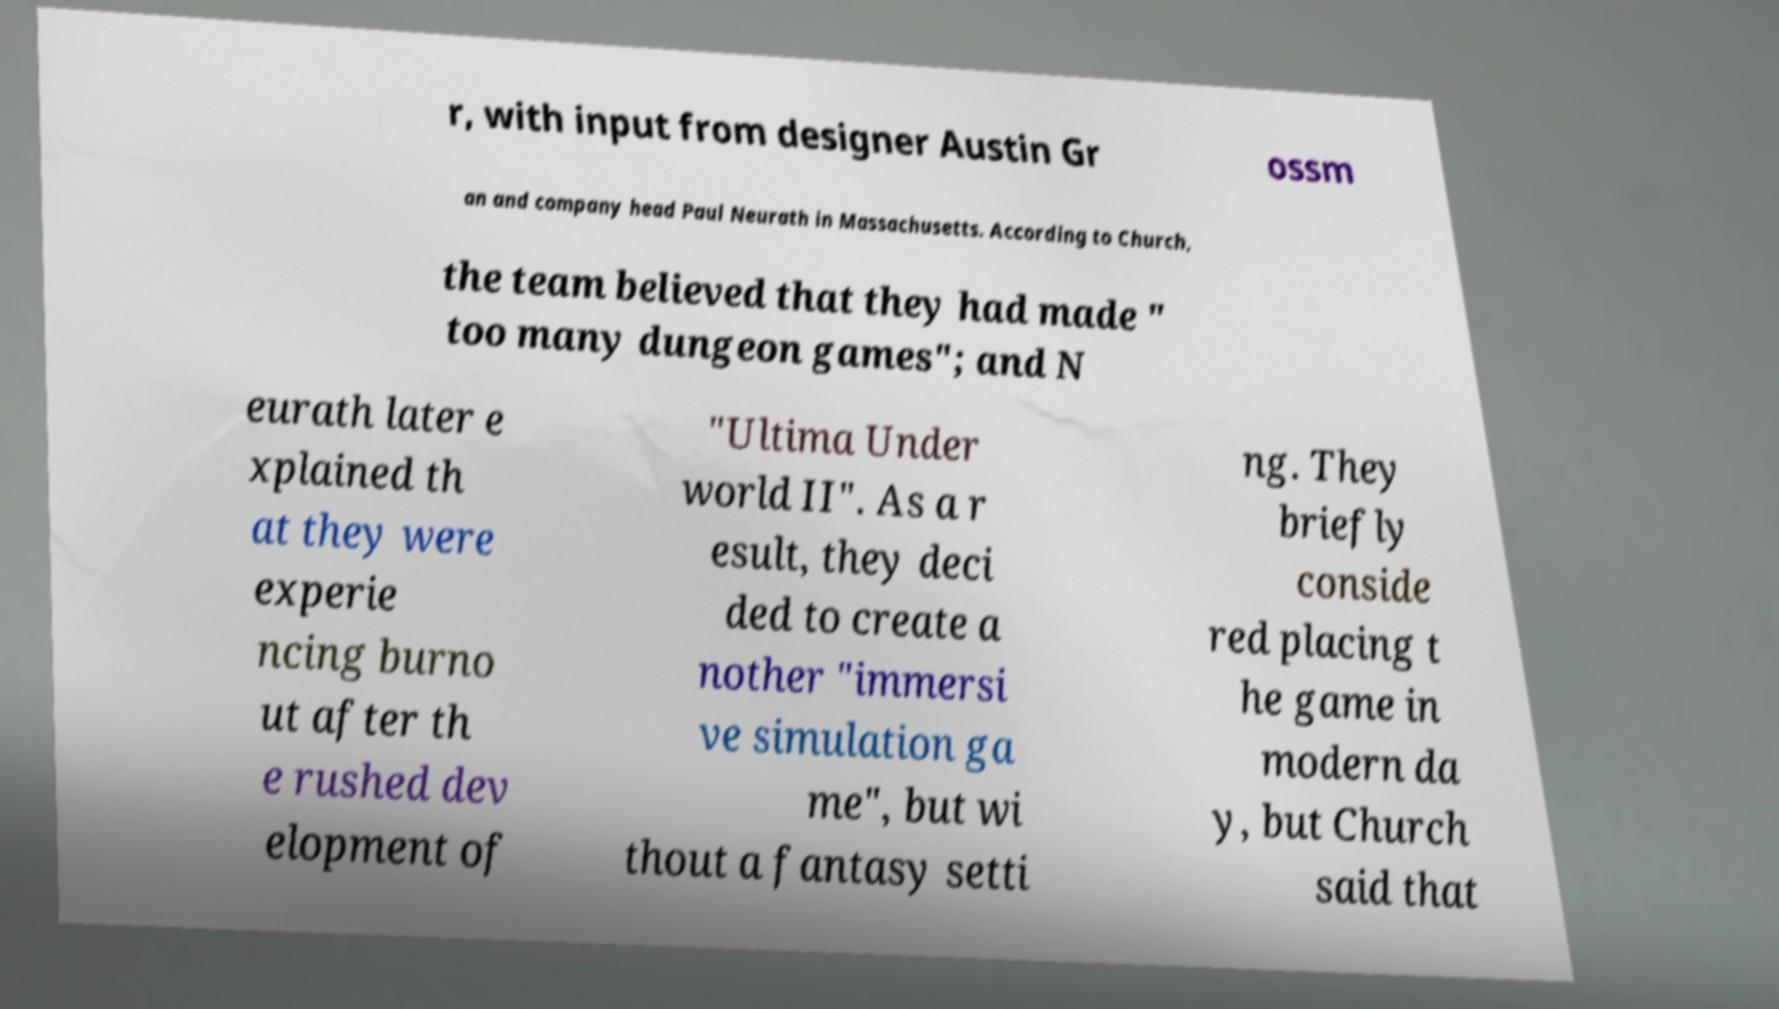I need the written content from this picture converted into text. Can you do that? r, with input from designer Austin Gr ossm an and company head Paul Neurath in Massachusetts. According to Church, the team believed that they had made " too many dungeon games"; and N eurath later e xplained th at they were experie ncing burno ut after th e rushed dev elopment of "Ultima Under world II". As a r esult, they deci ded to create a nother "immersi ve simulation ga me", but wi thout a fantasy setti ng. They briefly conside red placing t he game in modern da y, but Church said that 